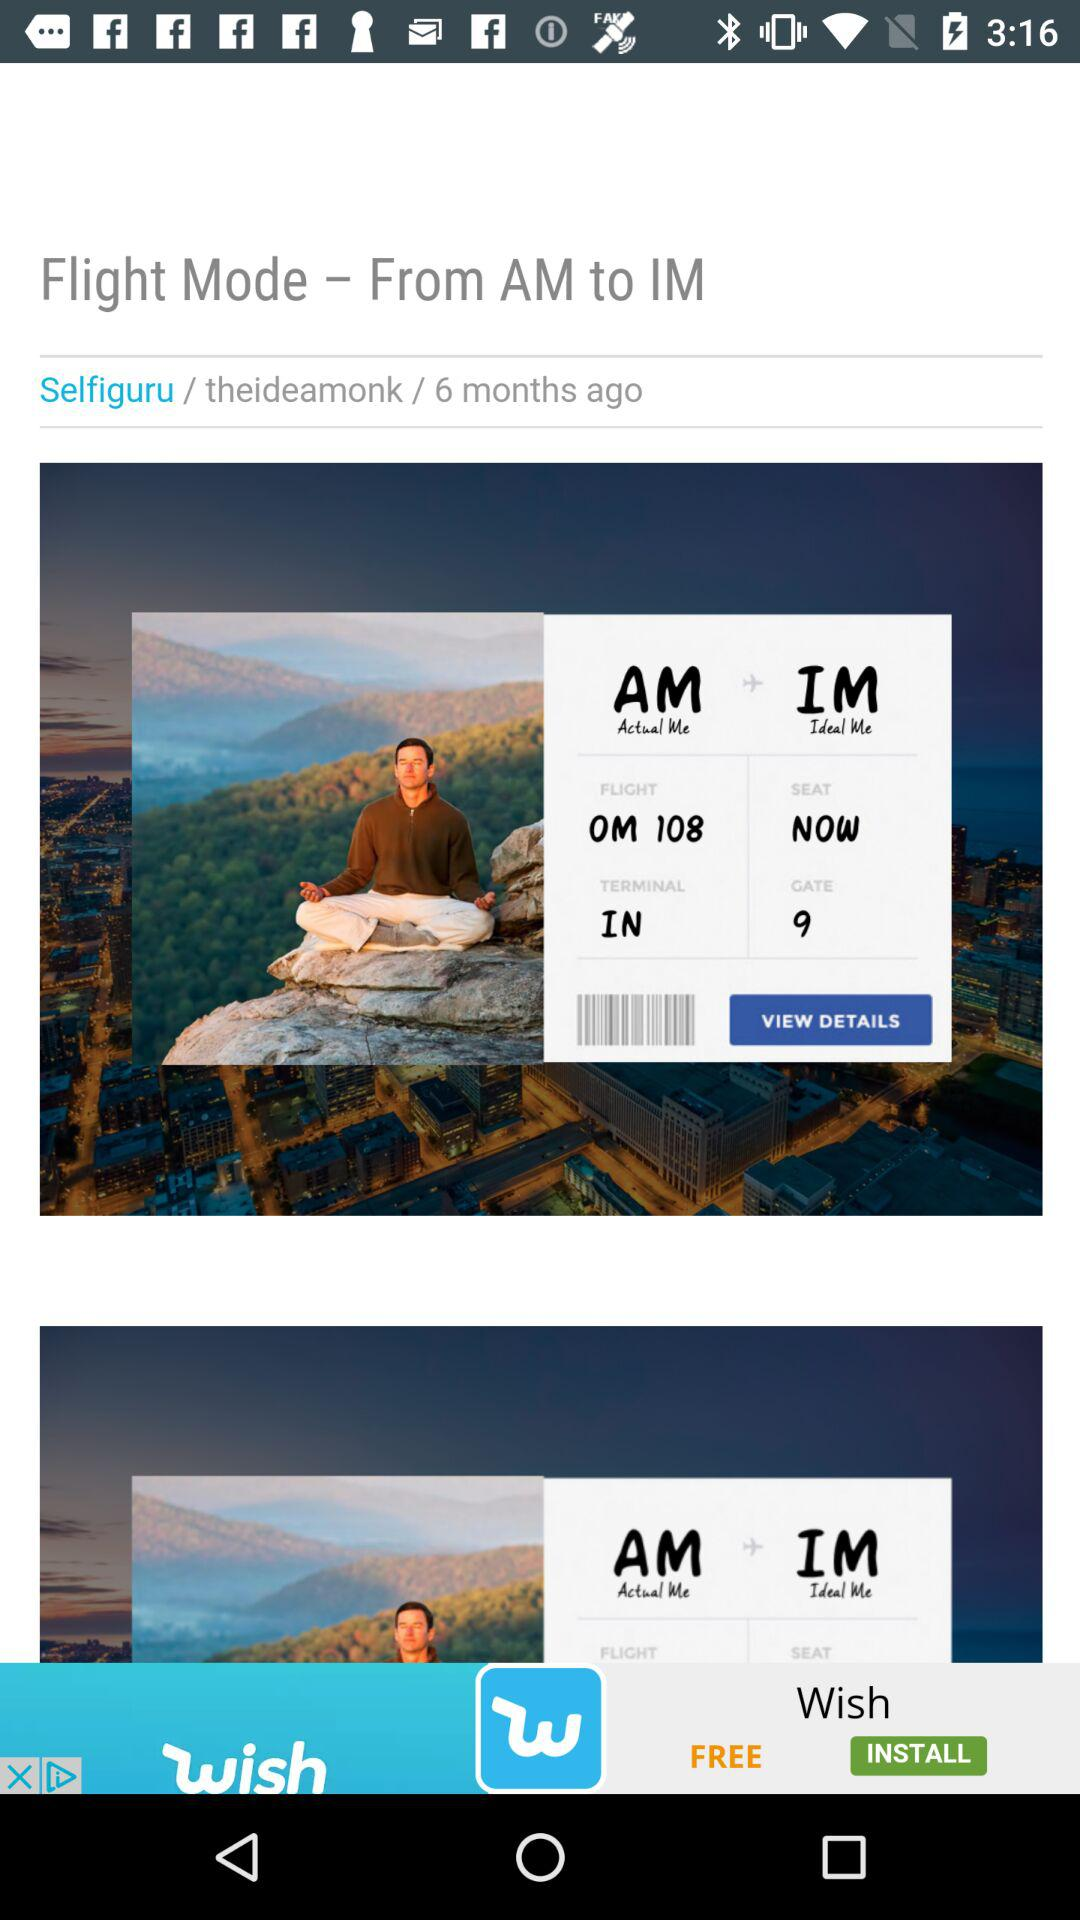What is the gate number? The gate number is 9. 